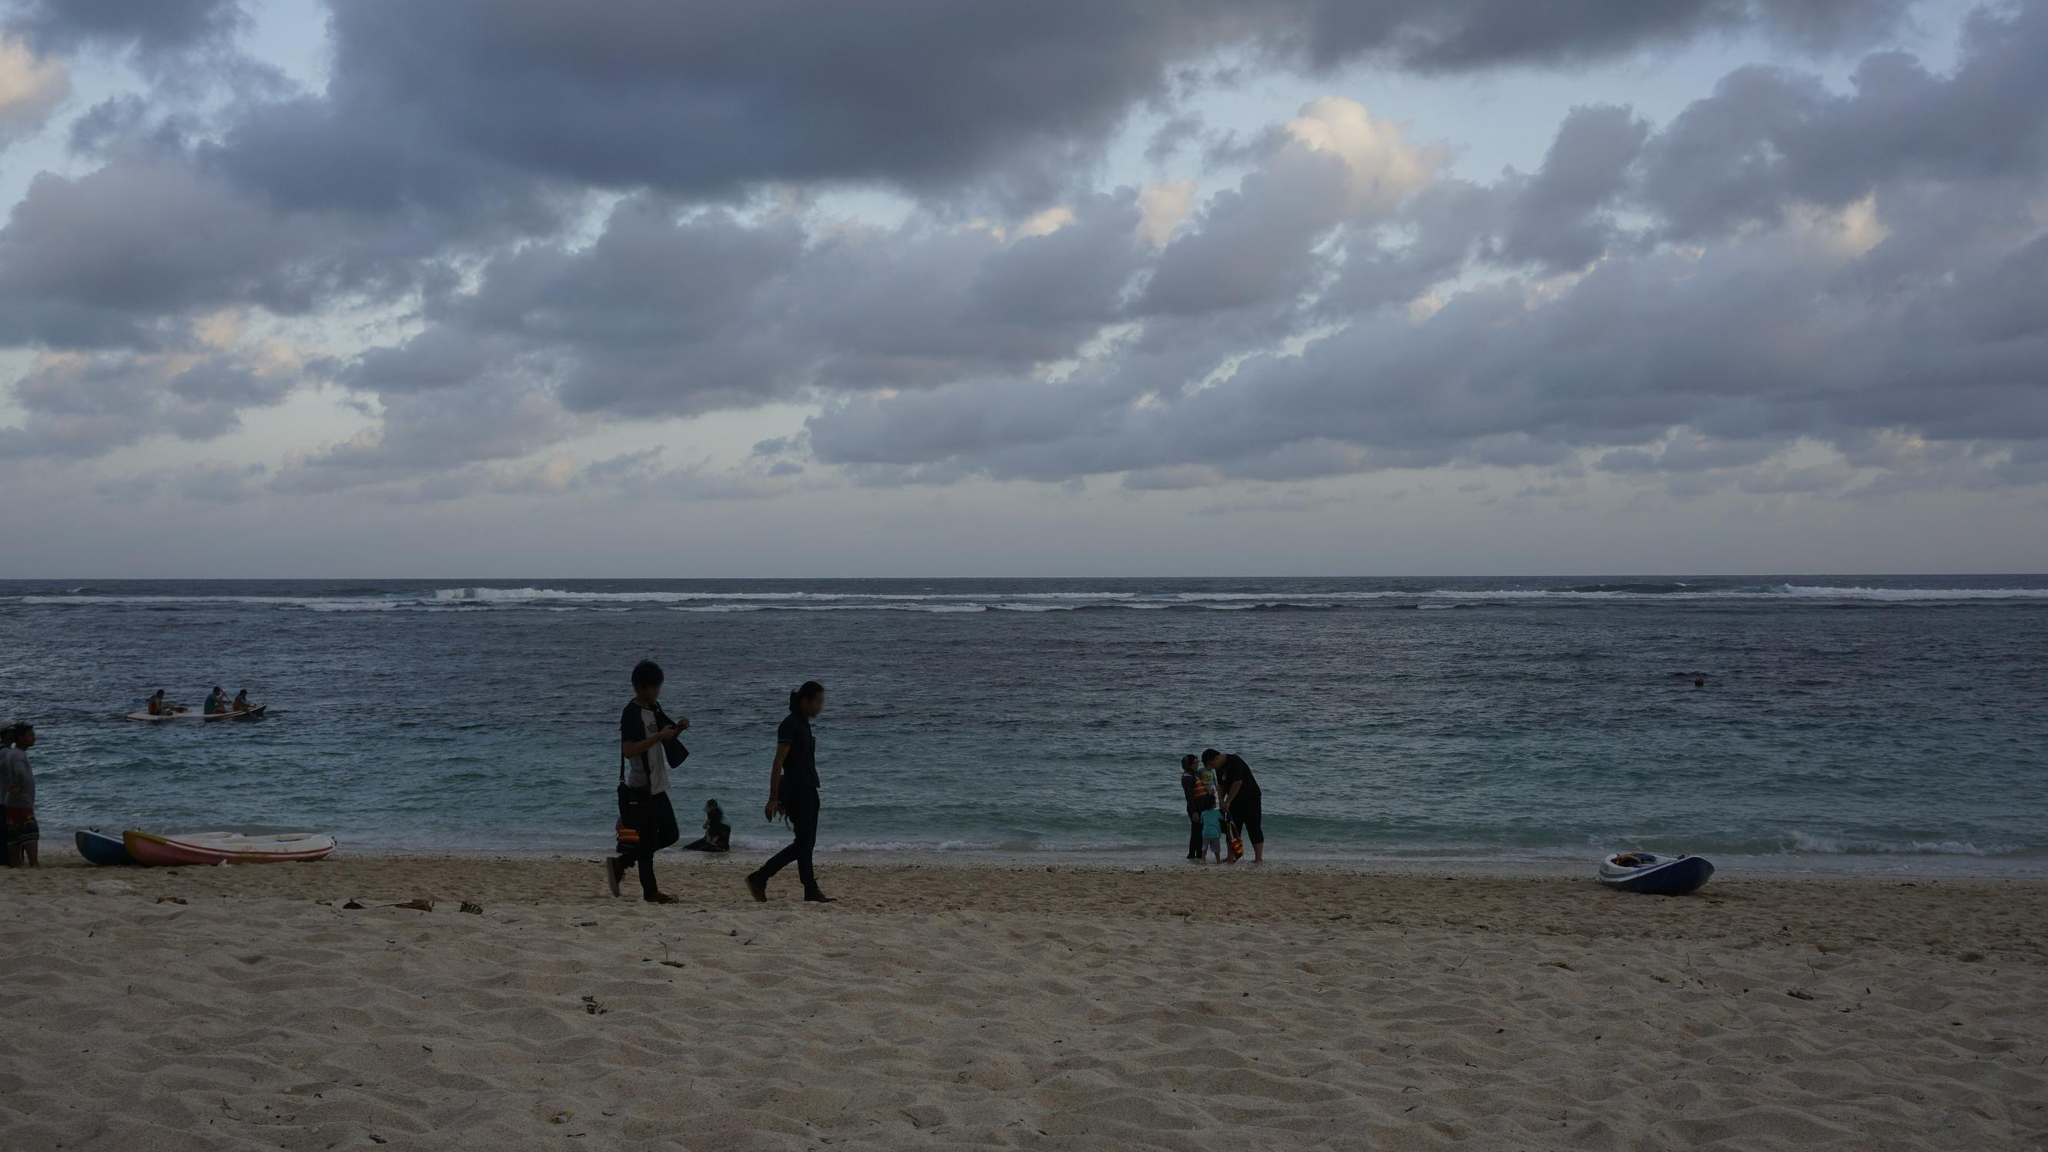How might this beach appear after a storm? Imagine a scenario. After a storm, this beach might look quite different. The calm and serene atmosphere would be replaced by signs of nature's recent upheaval. The once pristine sand could be littered with seaweed, driftwood, and other marine debris deposited by rough waves. Pools of rainwater might dot the shoreline, and the sand could appear darker and more compact due to the recent wet conditions.

The ocean itself might still exhibit remnants of the storm's fury, with larger waves crashing harder against the shore, and the water possibly looking murkier from stirred-up sediment. The sky could be filled with lingering clouds, slowly dispersing as the storm moves away, with patches of sunlight breaking through, creating a dramatic post-storm scene.

Amidst this raw, natural beauty, you might find people coming out to witness the aftermath, perhaps looking for interesting items washed up by the storm, or simply marveling at the force of nature. Children could be seen jumping in puddles or collecting shells that have been scattered across the sand. The beach would have a wild, untamed appeal, showcasing the power and unpredictable nature of the sea. Create a poetic description of what this scene might evoke. At the close of day, beneath a sky of gray, 
Upon the sandy shore, where whispers softly play, 
Waves caress the land in gentle, rhythmic sway, 
A dance eternal, in twilight's fading ray.

People stroll as shadows, in evening’s tender hush, 
Steps imprinted lightly in the soft, cool rush, 
The sea murmurs secrets in a tranquil, lulling hush, 
Nature's serenade as skies begin to blush.

Kayaks rest in color, against the muted ground, 
Bold in their repose, yet silent without sound, 
A contrast to the stillness, where ocean hues are found, 
In this coastal canvas where peace and life are bound.

Clouds gather 'cross the heavens, a tapestry of gray, 
Guardians of the twilight, as night begins its sway, 
Yet beauty thrives in quiet, at the edge of waning day, 
In the hues and hums of nature, where hearts and minds can stray. 